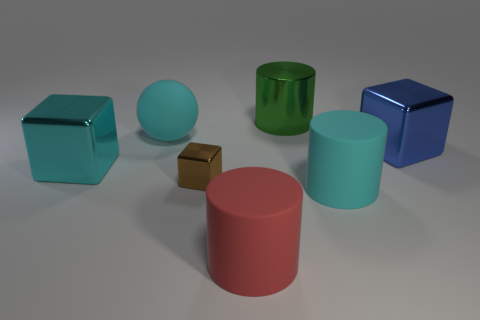Add 1 cyan blocks. How many objects exist? 8 Subtract 1 cylinders. How many cylinders are left? 2 Add 6 cyan rubber cylinders. How many cyan rubber cylinders are left? 7 Add 5 green things. How many green things exist? 6 Subtract 0 red cubes. How many objects are left? 7 Subtract all blocks. How many objects are left? 4 Subtract all large blue shiny things. Subtract all large cyan cylinders. How many objects are left? 5 